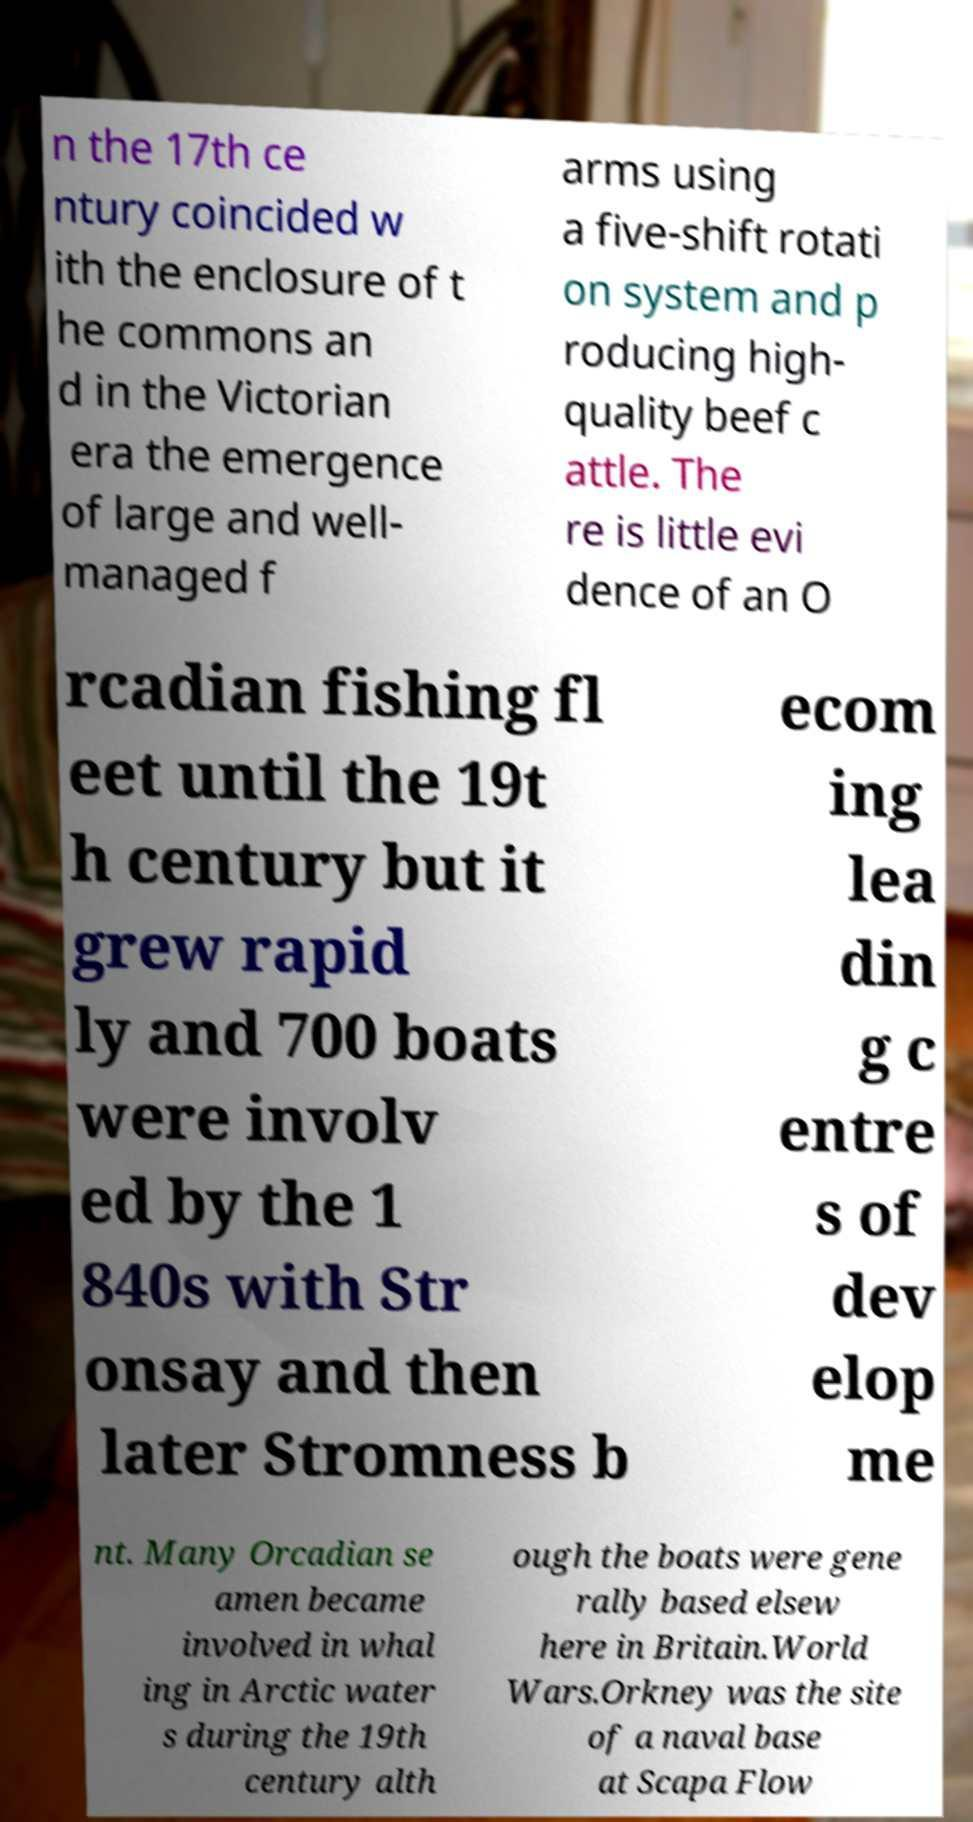There's text embedded in this image that I need extracted. Can you transcribe it verbatim? n the 17th ce ntury coincided w ith the enclosure of t he commons an d in the Victorian era the emergence of large and well- managed f arms using a five-shift rotati on system and p roducing high- quality beef c attle. The re is little evi dence of an O rcadian fishing fl eet until the 19t h century but it grew rapid ly and 700 boats were involv ed by the 1 840s with Str onsay and then later Stromness b ecom ing lea din g c entre s of dev elop me nt. Many Orcadian se amen became involved in whal ing in Arctic water s during the 19th century alth ough the boats were gene rally based elsew here in Britain.World Wars.Orkney was the site of a naval base at Scapa Flow 